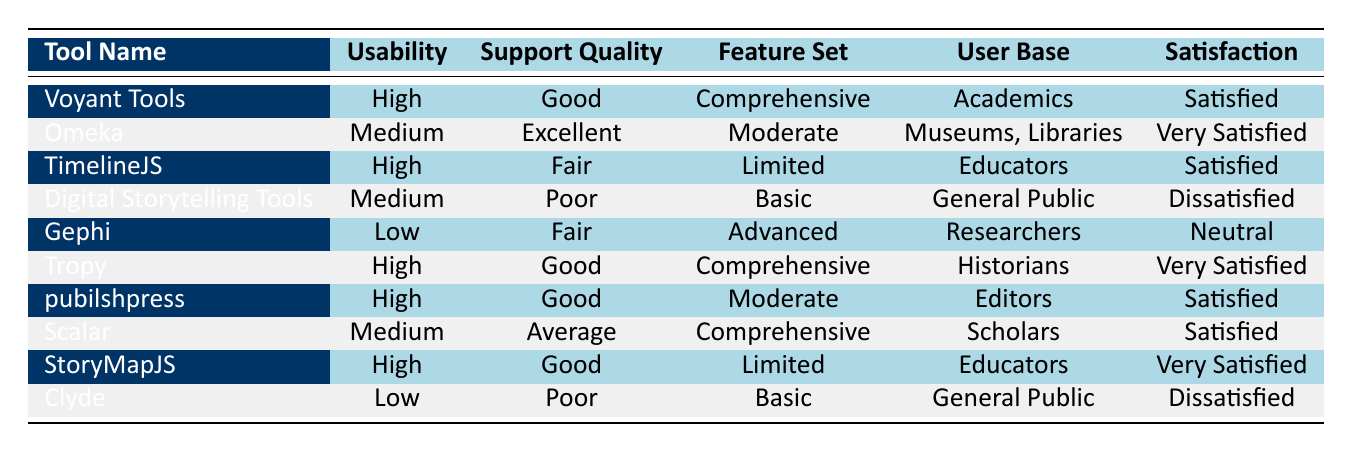What is the satisfaction level of Omeka? By locating the row corresponding to Omeka in the table, we can see the "Satisfaction" column states "Very Satisfied".
Answer: Very Satisfied How many tools have a high usability rating? Counting the entries in the "Usability" column, we find three tools (Voyant Tools, TimelineJS, Tropy, pubilshpress, StoryMapJS) with a high usability rating.
Answer: 5 Is the support quality for Digital Storytelling Tools marked as "Good"? Looking at the "Support Quality" column for Digital Storytelling Tools, it is actually marked as "Poor", hence the answer is no.
Answer: No What digital humanities tool has the highest satisfaction level? By examining the "Satisfaction" column, we have two entries for "Very Satisfied": Omeka and Tropy, but since both are "Very Satisfied", either could be considered as having the highest satisfaction level.
Answer: Omeka or Tropy If we categorize tools with "Comprehensive" feature sets, how many of those are rated "Satisfied"? There are three tools with "Comprehensive" feature sets: Voyant Tools, Tropy, and Scalar. Out of these, only Voyant Tools and Scalar are rated "Satisfied", while Tropy is "Very Satisfied". Thus, there are two tools rated "Satisfied".
Answer: 2 What is the user base for the tool with the highest support quality? By scanning the "Support Quality" column, Omeka is the only tool rated as "Excellent". Its user base, indicated in the "User Base" column, is marked as "Museums, Libraries".
Answer: Museums, Libraries Are there any tools rated "Dissatisfied"? In the "Satisfaction" column, we can find two tools: "Digital Storytelling Tools" and "Clyde" both marked as "Dissatisfied". Hence, the answer is yes.
Answer: Yes Which tool has the lowest usability rating and what is its satisfaction level? The tool with the lowest usability rating is "Clyde," which is marked as "Low". In the "Satisfaction" column, it's noted that its satisfaction level is "Dissatisfied".
Answer: Clyde, Dissatisfied 